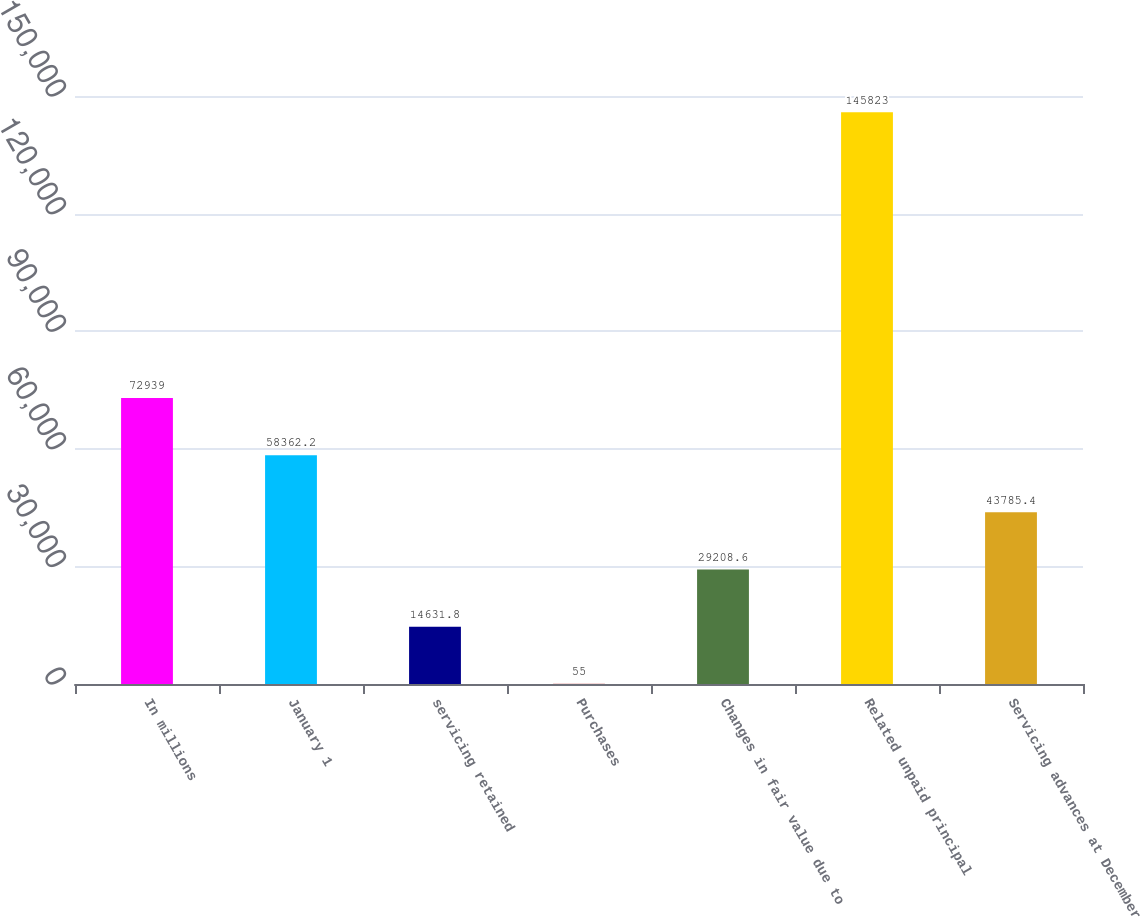Convert chart to OTSL. <chart><loc_0><loc_0><loc_500><loc_500><bar_chart><fcel>In millions<fcel>January 1<fcel>servicing retained<fcel>Purchases<fcel>Changes in fair value due to<fcel>Related unpaid principal<fcel>Servicing advances at December<nl><fcel>72939<fcel>58362.2<fcel>14631.8<fcel>55<fcel>29208.6<fcel>145823<fcel>43785.4<nl></chart> 